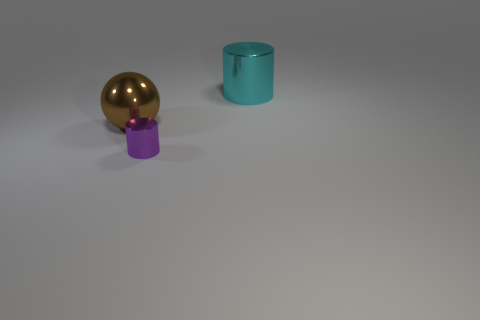What is the color of the cylinder that is to the right of the cylinder that is in front of the big metal thing that is left of the purple metallic thing? The cylinder to the right of the cylinder, which is itself positioned in front of a larger golden spherical object to the left of the purple metallic object, has a cyan color. It's interesting to note the subtle placement and color coordination among these simple yet elegantly rendered objects. 